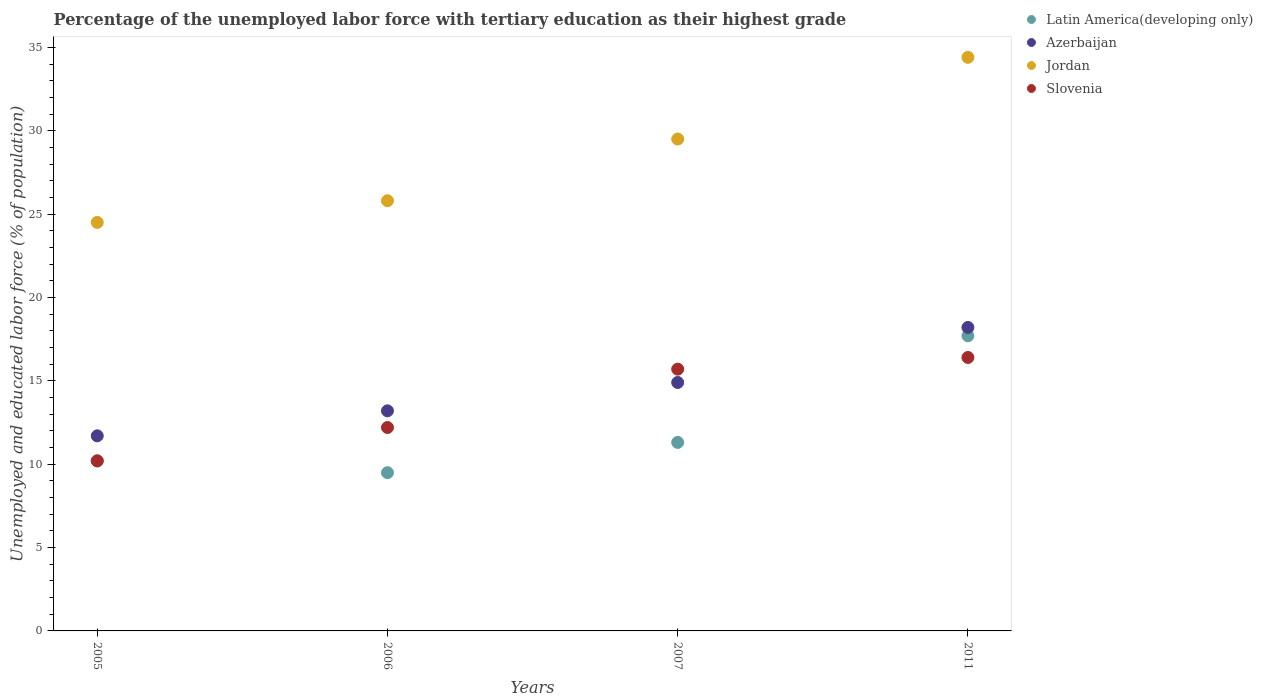What is the percentage of the unemployed labor force with tertiary education in Jordan in 2011?
Give a very brief answer. 34.4. Across all years, what is the maximum percentage of the unemployed labor force with tertiary education in Slovenia?
Provide a short and direct response. 16.4. Across all years, what is the minimum percentage of the unemployed labor force with tertiary education in Azerbaijan?
Make the answer very short. 11.7. In which year was the percentage of the unemployed labor force with tertiary education in Slovenia maximum?
Your answer should be very brief. 2011. What is the total percentage of the unemployed labor force with tertiary education in Azerbaijan in the graph?
Keep it short and to the point. 58. What is the difference between the percentage of the unemployed labor force with tertiary education in Jordan in 2005 and that in 2011?
Ensure brevity in your answer.  -9.9. What is the difference between the percentage of the unemployed labor force with tertiary education in Jordan in 2011 and the percentage of the unemployed labor force with tertiary education in Azerbaijan in 2005?
Provide a short and direct response. 22.7. What is the average percentage of the unemployed labor force with tertiary education in Latin America(developing only) per year?
Make the answer very short. 12.17. In the year 2006, what is the difference between the percentage of the unemployed labor force with tertiary education in Latin America(developing only) and percentage of the unemployed labor force with tertiary education in Jordan?
Provide a short and direct response. -16.31. What is the ratio of the percentage of the unemployed labor force with tertiary education in Slovenia in 2006 to that in 2007?
Offer a very short reply. 0.78. Is the percentage of the unemployed labor force with tertiary education in Latin America(developing only) in 2007 less than that in 2011?
Your answer should be very brief. Yes. Is the difference between the percentage of the unemployed labor force with tertiary education in Latin America(developing only) in 2005 and 2011 greater than the difference between the percentage of the unemployed labor force with tertiary education in Jordan in 2005 and 2011?
Your answer should be very brief. Yes. What is the difference between the highest and the second highest percentage of the unemployed labor force with tertiary education in Azerbaijan?
Your response must be concise. 3.3. What is the difference between the highest and the lowest percentage of the unemployed labor force with tertiary education in Slovenia?
Your answer should be compact. 6.2. In how many years, is the percentage of the unemployed labor force with tertiary education in Slovenia greater than the average percentage of the unemployed labor force with tertiary education in Slovenia taken over all years?
Make the answer very short. 2. Is the percentage of the unemployed labor force with tertiary education in Slovenia strictly less than the percentage of the unemployed labor force with tertiary education in Latin America(developing only) over the years?
Provide a short and direct response. No. How many dotlines are there?
Make the answer very short. 4. Are the values on the major ticks of Y-axis written in scientific E-notation?
Offer a terse response. No. Does the graph contain any zero values?
Provide a succinct answer. No. How are the legend labels stacked?
Your answer should be compact. Vertical. What is the title of the graph?
Your answer should be very brief. Percentage of the unemployed labor force with tertiary education as their highest grade. Does "Jamaica" appear as one of the legend labels in the graph?
Your answer should be compact. No. What is the label or title of the X-axis?
Provide a succinct answer. Years. What is the label or title of the Y-axis?
Give a very brief answer. Unemployed and educated labor force (% of population). What is the Unemployed and educated labor force (% of population) in Latin America(developing only) in 2005?
Ensure brevity in your answer.  10.2. What is the Unemployed and educated labor force (% of population) in Azerbaijan in 2005?
Provide a succinct answer. 11.7. What is the Unemployed and educated labor force (% of population) in Slovenia in 2005?
Keep it short and to the point. 10.2. What is the Unemployed and educated labor force (% of population) in Latin America(developing only) in 2006?
Provide a short and direct response. 9.49. What is the Unemployed and educated labor force (% of population) of Azerbaijan in 2006?
Offer a very short reply. 13.2. What is the Unemployed and educated labor force (% of population) of Jordan in 2006?
Ensure brevity in your answer.  25.8. What is the Unemployed and educated labor force (% of population) in Slovenia in 2006?
Give a very brief answer. 12.2. What is the Unemployed and educated labor force (% of population) in Latin America(developing only) in 2007?
Provide a succinct answer. 11.31. What is the Unemployed and educated labor force (% of population) of Azerbaijan in 2007?
Offer a terse response. 14.9. What is the Unemployed and educated labor force (% of population) of Jordan in 2007?
Make the answer very short. 29.5. What is the Unemployed and educated labor force (% of population) in Slovenia in 2007?
Offer a terse response. 15.7. What is the Unemployed and educated labor force (% of population) of Latin America(developing only) in 2011?
Ensure brevity in your answer.  17.7. What is the Unemployed and educated labor force (% of population) in Azerbaijan in 2011?
Give a very brief answer. 18.2. What is the Unemployed and educated labor force (% of population) of Jordan in 2011?
Offer a very short reply. 34.4. What is the Unemployed and educated labor force (% of population) in Slovenia in 2011?
Provide a succinct answer. 16.4. Across all years, what is the maximum Unemployed and educated labor force (% of population) of Latin America(developing only)?
Your response must be concise. 17.7. Across all years, what is the maximum Unemployed and educated labor force (% of population) of Azerbaijan?
Give a very brief answer. 18.2. Across all years, what is the maximum Unemployed and educated labor force (% of population) of Jordan?
Provide a short and direct response. 34.4. Across all years, what is the maximum Unemployed and educated labor force (% of population) of Slovenia?
Keep it short and to the point. 16.4. Across all years, what is the minimum Unemployed and educated labor force (% of population) in Latin America(developing only)?
Your answer should be compact. 9.49. Across all years, what is the minimum Unemployed and educated labor force (% of population) in Azerbaijan?
Keep it short and to the point. 11.7. Across all years, what is the minimum Unemployed and educated labor force (% of population) in Jordan?
Your answer should be compact. 24.5. Across all years, what is the minimum Unemployed and educated labor force (% of population) in Slovenia?
Provide a succinct answer. 10.2. What is the total Unemployed and educated labor force (% of population) of Latin America(developing only) in the graph?
Your response must be concise. 48.69. What is the total Unemployed and educated labor force (% of population) of Jordan in the graph?
Your response must be concise. 114.2. What is the total Unemployed and educated labor force (% of population) of Slovenia in the graph?
Provide a short and direct response. 54.5. What is the difference between the Unemployed and educated labor force (% of population) in Latin America(developing only) in 2005 and that in 2006?
Give a very brief answer. 0.71. What is the difference between the Unemployed and educated labor force (% of population) of Azerbaijan in 2005 and that in 2006?
Ensure brevity in your answer.  -1.5. What is the difference between the Unemployed and educated labor force (% of population) of Latin America(developing only) in 2005 and that in 2007?
Offer a very short reply. -1.11. What is the difference between the Unemployed and educated labor force (% of population) of Latin America(developing only) in 2005 and that in 2011?
Your response must be concise. -7.51. What is the difference between the Unemployed and educated labor force (% of population) in Latin America(developing only) in 2006 and that in 2007?
Provide a succinct answer. -1.82. What is the difference between the Unemployed and educated labor force (% of population) in Latin America(developing only) in 2006 and that in 2011?
Your response must be concise. -8.21. What is the difference between the Unemployed and educated labor force (% of population) in Azerbaijan in 2006 and that in 2011?
Give a very brief answer. -5. What is the difference between the Unemployed and educated labor force (% of population) in Jordan in 2006 and that in 2011?
Your answer should be very brief. -8.6. What is the difference between the Unemployed and educated labor force (% of population) of Slovenia in 2006 and that in 2011?
Provide a succinct answer. -4.2. What is the difference between the Unemployed and educated labor force (% of population) in Latin America(developing only) in 2007 and that in 2011?
Make the answer very short. -6.4. What is the difference between the Unemployed and educated labor force (% of population) in Jordan in 2007 and that in 2011?
Your answer should be very brief. -4.9. What is the difference between the Unemployed and educated labor force (% of population) in Latin America(developing only) in 2005 and the Unemployed and educated labor force (% of population) in Azerbaijan in 2006?
Your response must be concise. -3. What is the difference between the Unemployed and educated labor force (% of population) in Latin America(developing only) in 2005 and the Unemployed and educated labor force (% of population) in Jordan in 2006?
Your answer should be compact. -15.6. What is the difference between the Unemployed and educated labor force (% of population) of Latin America(developing only) in 2005 and the Unemployed and educated labor force (% of population) of Slovenia in 2006?
Ensure brevity in your answer.  -2. What is the difference between the Unemployed and educated labor force (% of population) of Azerbaijan in 2005 and the Unemployed and educated labor force (% of population) of Jordan in 2006?
Your answer should be very brief. -14.1. What is the difference between the Unemployed and educated labor force (% of population) in Azerbaijan in 2005 and the Unemployed and educated labor force (% of population) in Slovenia in 2006?
Make the answer very short. -0.5. What is the difference between the Unemployed and educated labor force (% of population) in Latin America(developing only) in 2005 and the Unemployed and educated labor force (% of population) in Azerbaijan in 2007?
Offer a terse response. -4.7. What is the difference between the Unemployed and educated labor force (% of population) in Latin America(developing only) in 2005 and the Unemployed and educated labor force (% of population) in Jordan in 2007?
Make the answer very short. -19.3. What is the difference between the Unemployed and educated labor force (% of population) in Latin America(developing only) in 2005 and the Unemployed and educated labor force (% of population) in Slovenia in 2007?
Your response must be concise. -5.5. What is the difference between the Unemployed and educated labor force (% of population) in Azerbaijan in 2005 and the Unemployed and educated labor force (% of population) in Jordan in 2007?
Offer a very short reply. -17.8. What is the difference between the Unemployed and educated labor force (% of population) of Jordan in 2005 and the Unemployed and educated labor force (% of population) of Slovenia in 2007?
Your answer should be very brief. 8.8. What is the difference between the Unemployed and educated labor force (% of population) of Latin America(developing only) in 2005 and the Unemployed and educated labor force (% of population) of Azerbaijan in 2011?
Provide a succinct answer. -8. What is the difference between the Unemployed and educated labor force (% of population) in Latin America(developing only) in 2005 and the Unemployed and educated labor force (% of population) in Jordan in 2011?
Offer a terse response. -24.2. What is the difference between the Unemployed and educated labor force (% of population) of Latin America(developing only) in 2005 and the Unemployed and educated labor force (% of population) of Slovenia in 2011?
Ensure brevity in your answer.  -6.2. What is the difference between the Unemployed and educated labor force (% of population) of Azerbaijan in 2005 and the Unemployed and educated labor force (% of population) of Jordan in 2011?
Provide a short and direct response. -22.7. What is the difference between the Unemployed and educated labor force (% of population) in Azerbaijan in 2005 and the Unemployed and educated labor force (% of population) in Slovenia in 2011?
Your response must be concise. -4.7. What is the difference between the Unemployed and educated labor force (% of population) in Jordan in 2005 and the Unemployed and educated labor force (% of population) in Slovenia in 2011?
Offer a very short reply. 8.1. What is the difference between the Unemployed and educated labor force (% of population) in Latin America(developing only) in 2006 and the Unemployed and educated labor force (% of population) in Azerbaijan in 2007?
Provide a short and direct response. -5.41. What is the difference between the Unemployed and educated labor force (% of population) in Latin America(developing only) in 2006 and the Unemployed and educated labor force (% of population) in Jordan in 2007?
Your answer should be very brief. -20.01. What is the difference between the Unemployed and educated labor force (% of population) of Latin America(developing only) in 2006 and the Unemployed and educated labor force (% of population) of Slovenia in 2007?
Provide a short and direct response. -6.21. What is the difference between the Unemployed and educated labor force (% of population) of Azerbaijan in 2006 and the Unemployed and educated labor force (% of population) of Jordan in 2007?
Your answer should be very brief. -16.3. What is the difference between the Unemployed and educated labor force (% of population) in Latin America(developing only) in 2006 and the Unemployed and educated labor force (% of population) in Azerbaijan in 2011?
Make the answer very short. -8.71. What is the difference between the Unemployed and educated labor force (% of population) of Latin America(developing only) in 2006 and the Unemployed and educated labor force (% of population) of Jordan in 2011?
Ensure brevity in your answer.  -24.91. What is the difference between the Unemployed and educated labor force (% of population) of Latin America(developing only) in 2006 and the Unemployed and educated labor force (% of population) of Slovenia in 2011?
Offer a terse response. -6.91. What is the difference between the Unemployed and educated labor force (% of population) of Azerbaijan in 2006 and the Unemployed and educated labor force (% of population) of Jordan in 2011?
Your answer should be very brief. -21.2. What is the difference between the Unemployed and educated labor force (% of population) of Jordan in 2006 and the Unemployed and educated labor force (% of population) of Slovenia in 2011?
Offer a very short reply. 9.4. What is the difference between the Unemployed and educated labor force (% of population) in Latin America(developing only) in 2007 and the Unemployed and educated labor force (% of population) in Azerbaijan in 2011?
Make the answer very short. -6.89. What is the difference between the Unemployed and educated labor force (% of population) of Latin America(developing only) in 2007 and the Unemployed and educated labor force (% of population) of Jordan in 2011?
Give a very brief answer. -23.09. What is the difference between the Unemployed and educated labor force (% of population) of Latin America(developing only) in 2007 and the Unemployed and educated labor force (% of population) of Slovenia in 2011?
Make the answer very short. -5.09. What is the difference between the Unemployed and educated labor force (% of population) of Azerbaijan in 2007 and the Unemployed and educated labor force (% of population) of Jordan in 2011?
Offer a very short reply. -19.5. What is the difference between the Unemployed and educated labor force (% of population) in Azerbaijan in 2007 and the Unemployed and educated labor force (% of population) in Slovenia in 2011?
Ensure brevity in your answer.  -1.5. What is the difference between the Unemployed and educated labor force (% of population) of Jordan in 2007 and the Unemployed and educated labor force (% of population) of Slovenia in 2011?
Keep it short and to the point. 13.1. What is the average Unemployed and educated labor force (% of population) of Latin America(developing only) per year?
Your answer should be compact. 12.17. What is the average Unemployed and educated labor force (% of population) in Jordan per year?
Ensure brevity in your answer.  28.55. What is the average Unemployed and educated labor force (% of population) of Slovenia per year?
Your answer should be compact. 13.62. In the year 2005, what is the difference between the Unemployed and educated labor force (% of population) of Latin America(developing only) and Unemployed and educated labor force (% of population) of Azerbaijan?
Keep it short and to the point. -1.5. In the year 2005, what is the difference between the Unemployed and educated labor force (% of population) of Latin America(developing only) and Unemployed and educated labor force (% of population) of Jordan?
Your response must be concise. -14.3. In the year 2005, what is the difference between the Unemployed and educated labor force (% of population) in Latin America(developing only) and Unemployed and educated labor force (% of population) in Slovenia?
Provide a short and direct response. -0. In the year 2006, what is the difference between the Unemployed and educated labor force (% of population) in Latin America(developing only) and Unemployed and educated labor force (% of population) in Azerbaijan?
Offer a terse response. -3.71. In the year 2006, what is the difference between the Unemployed and educated labor force (% of population) in Latin America(developing only) and Unemployed and educated labor force (% of population) in Jordan?
Offer a very short reply. -16.31. In the year 2006, what is the difference between the Unemployed and educated labor force (% of population) in Latin America(developing only) and Unemployed and educated labor force (% of population) in Slovenia?
Offer a terse response. -2.71. In the year 2006, what is the difference between the Unemployed and educated labor force (% of population) of Azerbaijan and Unemployed and educated labor force (% of population) of Slovenia?
Your response must be concise. 1. In the year 2007, what is the difference between the Unemployed and educated labor force (% of population) in Latin America(developing only) and Unemployed and educated labor force (% of population) in Azerbaijan?
Give a very brief answer. -3.59. In the year 2007, what is the difference between the Unemployed and educated labor force (% of population) in Latin America(developing only) and Unemployed and educated labor force (% of population) in Jordan?
Ensure brevity in your answer.  -18.19. In the year 2007, what is the difference between the Unemployed and educated labor force (% of population) in Latin America(developing only) and Unemployed and educated labor force (% of population) in Slovenia?
Offer a terse response. -4.39. In the year 2007, what is the difference between the Unemployed and educated labor force (% of population) in Azerbaijan and Unemployed and educated labor force (% of population) in Jordan?
Offer a very short reply. -14.6. In the year 2011, what is the difference between the Unemployed and educated labor force (% of population) in Latin America(developing only) and Unemployed and educated labor force (% of population) in Azerbaijan?
Provide a short and direct response. -0.5. In the year 2011, what is the difference between the Unemployed and educated labor force (% of population) in Latin America(developing only) and Unemployed and educated labor force (% of population) in Jordan?
Your answer should be compact. -16.7. In the year 2011, what is the difference between the Unemployed and educated labor force (% of population) of Latin America(developing only) and Unemployed and educated labor force (% of population) of Slovenia?
Offer a very short reply. 1.3. In the year 2011, what is the difference between the Unemployed and educated labor force (% of population) in Azerbaijan and Unemployed and educated labor force (% of population) in Jordan?
Your answer should be compact. -16.2. What is the ratio of the Unemployed and educated labor force (% of population) of Latin America(developing only) in 2005 to that in 2006?
Provide a succinct answer. 1.07. What is the ratio of the Unemployed and educated labor force (% of population) in Azerbaijan in 2005 to that in 2006?
Your response must be concise. 0.89. What is the ratio of the Unemployed and educated labor force (% of population) in Jordan in 2005 to that in 2006?
Your response must be concise. 0.95. What is the ratio of the Unemployed and educated labor force (% of population) in Slovenia in 2005 to that in 2006?
Offer a terse response. 0.84. What is the ratio of the Unemployed and educated labor force (% of population) in Latin America(developing only) in 2005 to that in 2007?
Provide a short and direct response. 0.9. What is the ratio of the Unemployed and educated labor force (% of population) in Azerbaijan in 2005 to that in 2007?
Make the answer very short. 0.79. What is the ratio of the Unemployed and educated labor force (% of population) in Jordan in 2005 to that in 2007?
Provide a succinct answer. 0.83. What is the ratio of the Unemployed and educated labor force (% of population) in Slovenia in 2005 to that in 2007?
Offer a terse response. 0.65. What is the ratio of the Unemployed and educated labor force (% of population) of Latin America(developing only) in 2005 to that in 2011?
Your response must be concise. 0.58. What is the ratio of the Unemployed and educated labor force (% of population) of Azerbaijan in 2005 to that in 2011?
Make the answer very short. 0.64. What is the ratio of the Unemployed and educated labor force (% of population) in Jordan in 2005 to that in 2011?
Keep it short and to the point. 0.71. What is the ratio of the Unemployed and educated labor force (% of population) of Slovenia in 2005 to that in 2011?
Your response must be concise. 0.62. What is the ratio of the Unemployed and educated labor force (% of population) in Latin America(developing only) in 2006 to that in 2007?
Your answer should be very brief. 0.84. What is the ratio of the Unemployed and educated labor force (% of population) in Azerbaijan in 2006 to that in 2007?
Give a very brief answer. 0.89. What is the ratio of the Unemployed and educated labor force (% of population) in Jordan in 2006 to that in 2007?
Your answer should be compact. 0.87. What is the ratio of the Unemployed and educated labor force (% of population) of Slovenia in 2006 to that in 2007?
Make the answer very short. 0.78. What is the ratio of the Unemployed and educated labor force (% of population) of Latin America(developing only) in 2006 to that in 2011?
Give a very brief answer. 0.54. What is the ratio of the Unemployed and educated labor force (% of population) in Azerbaijan in 2006 to that in 2011?
Keep it short and to the point. 0.73. What is the ratio of the Unemployed and educated labor force (% of population) of Slovenia in 2006 to that in 2011?
Your answer should be very brief. 0.74. What is the ratio of the Unemployed and educated labor force (% of population) of Latin America(developing only) in 2007 to that in 2011?
Make the answer very short. 0.64. What is the ratio of the Unemployed and educated labor force (% of population) of Azerbaijan in 2007 to that in 2011?
Make the answer very short. 0.82. What is the ratio of the Unemployed and educated labor force (% of population) in Jordan in 2007 to that in 2011?
Provide a succinct answer. 0.86. What is the ratio of the Unemployed and educated labor force (% of population) of Slovenia in 2007 to that in 2011?
Ensure brevity in your answer.  0.96. What is the difference between the highest and the second highest Unemployed and educated labor force (% of population) of Latin America(developing only)?
Offer a very short reply. 6.4. What is the difference between the highest and the second highest Unemployed and educated labor force (% of population) of Azerbaijan?
Offer a very short reply. 3.3. What is the difference between the highest and the second highest Unemployed and educated labor force (% of population) of Jordan?
Give a very brief answer. 4.9. What is the difference between the highest and the lowest Unemployed and educated labor force (% of population) in Latin America(developing only)?
Give a very brief answer. 8.21. What is the difference between the highest and the lowest Unemployed and educated labor force (% of population) in Azerbaijan?
Offer a very short reply. 6.5. 